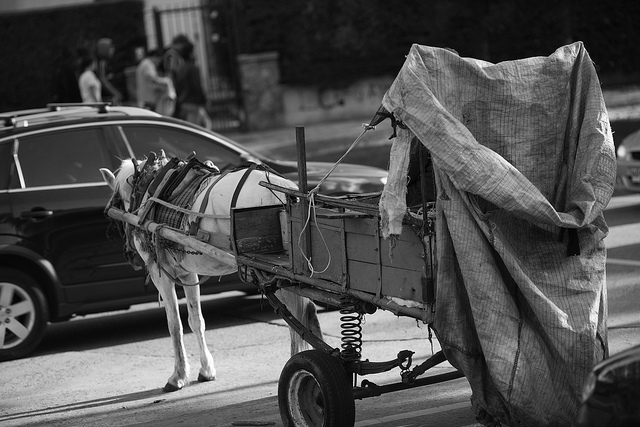<image>Does this vehicle travel by air or by water? It is ambiguous whether this vehicle travels by air or water. It appears that the vehicle travels by either land or ground. Does this vehicle travel by air or by water? It is ambiguous if this vehicle travels by air or by water. It can be seen as both on ground and on water. 